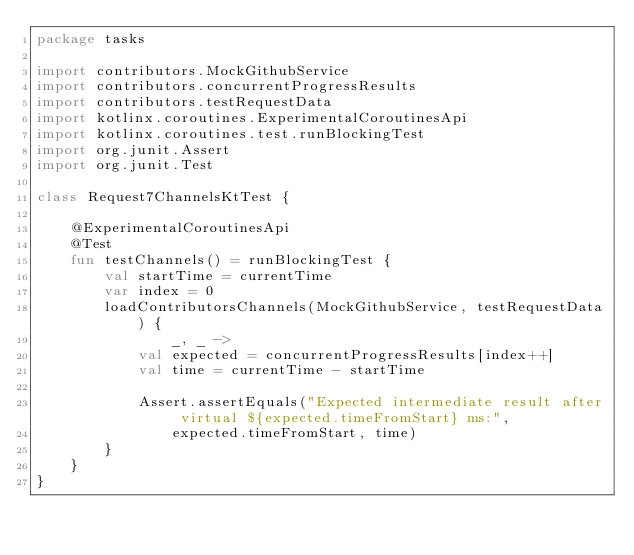Convert code to text. <code><loc_0><loc_0><loc_500><loc_500><_Kotlin_>package tasks

import contributors.MockGithubService
import contributors.concurrentProgressResults
import contributors.testRequestData
import kotlinx.coroutines.ExperimentalCoroutinesApi
import kotlinx.coroutines.test.runBlockingTest
import org.junit.Assert
import org.junit.Test

class Request7ChannelsKtTest {

    @ExperimentalCoroutinesApi
    @Test
    fun testChannels() = runBlockingTest {
        val startTime = currentTime
        var index = 0
        loadContributorsChannels(MockGithubService, testRequestData) {
                _, _ ->
            val expected = concurrentProgressResults[index++]
            val time = currentTime - startTime

            Assert.assertEquals("Expected intermediate result after virtual ${expected.timeFromStart} ms:",
                expected.timeFromStart, time)
        }
    }
}
</code> 